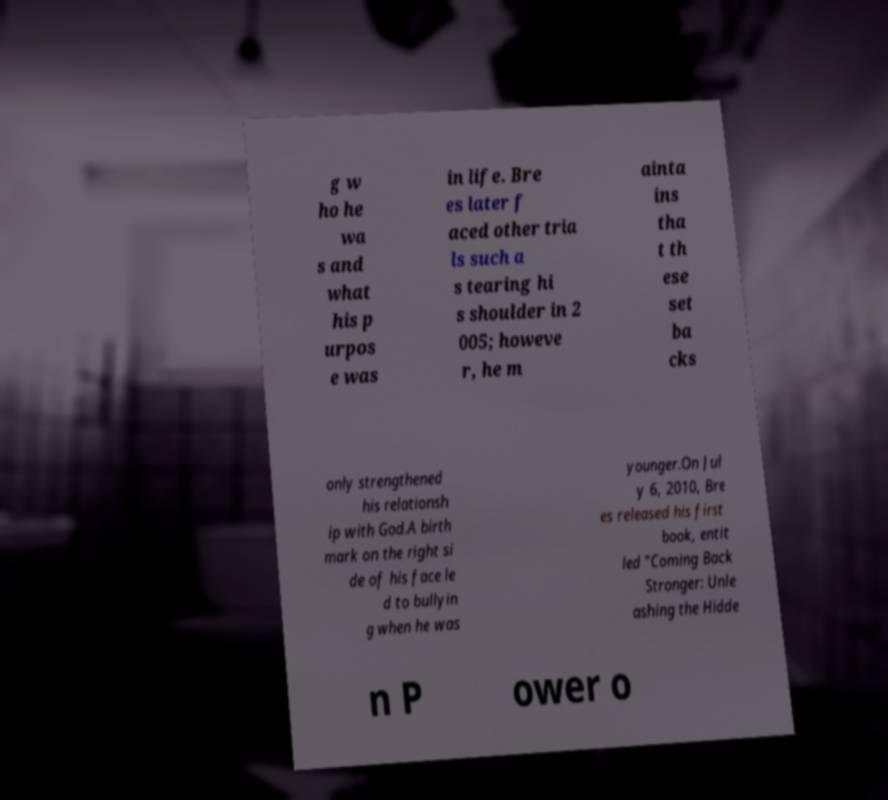Please read and relay the text visible in this image. What does it say? g w ho he wa s and what his p urpos e was in life. Bre es later f aced other tria ls such a s tearing hi s shoulder in 2 005; howeve r, he m ainta ins tha t th ese set ba cks only strengthened his relationsh ip with God.A birth mark on the right si de of his face le d to bullyin g when he was younger.On Jul y 6, 2010, Bre es released his first book, entit led "Coming Back Stronger: Unle ashing the Hidde n P ower o 